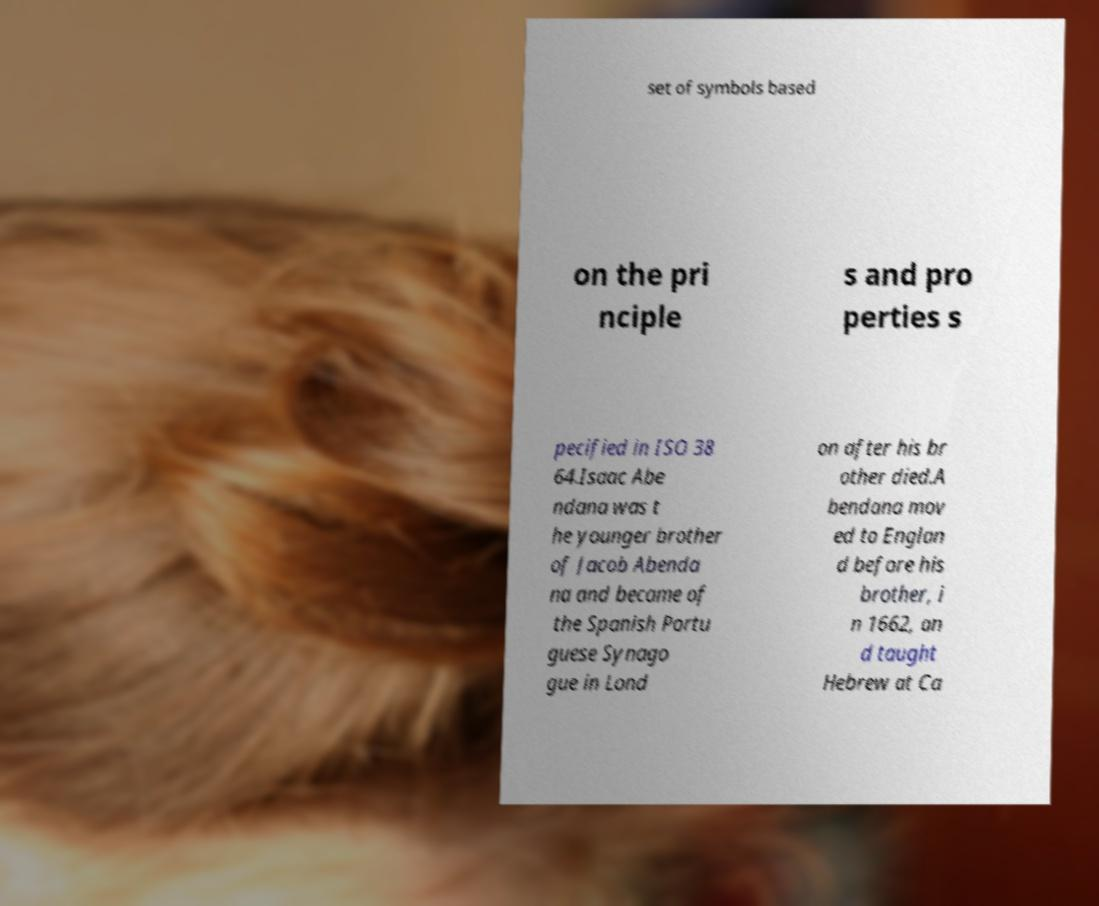For documentation purposes, I need the text within this image transcribed. Could you provide that? set of symbols based on the pri nciple s and pro perties s pecified in ISO 38 64.Isaac Abe ndana was t he younger brother of Jacob Abenda na and became of the Spanish Portu guese Synago gue in Lond on after his br other died.A bendana mov ed to Englan d before his brother, i n 1662, an d taught Hebrew at Ca 